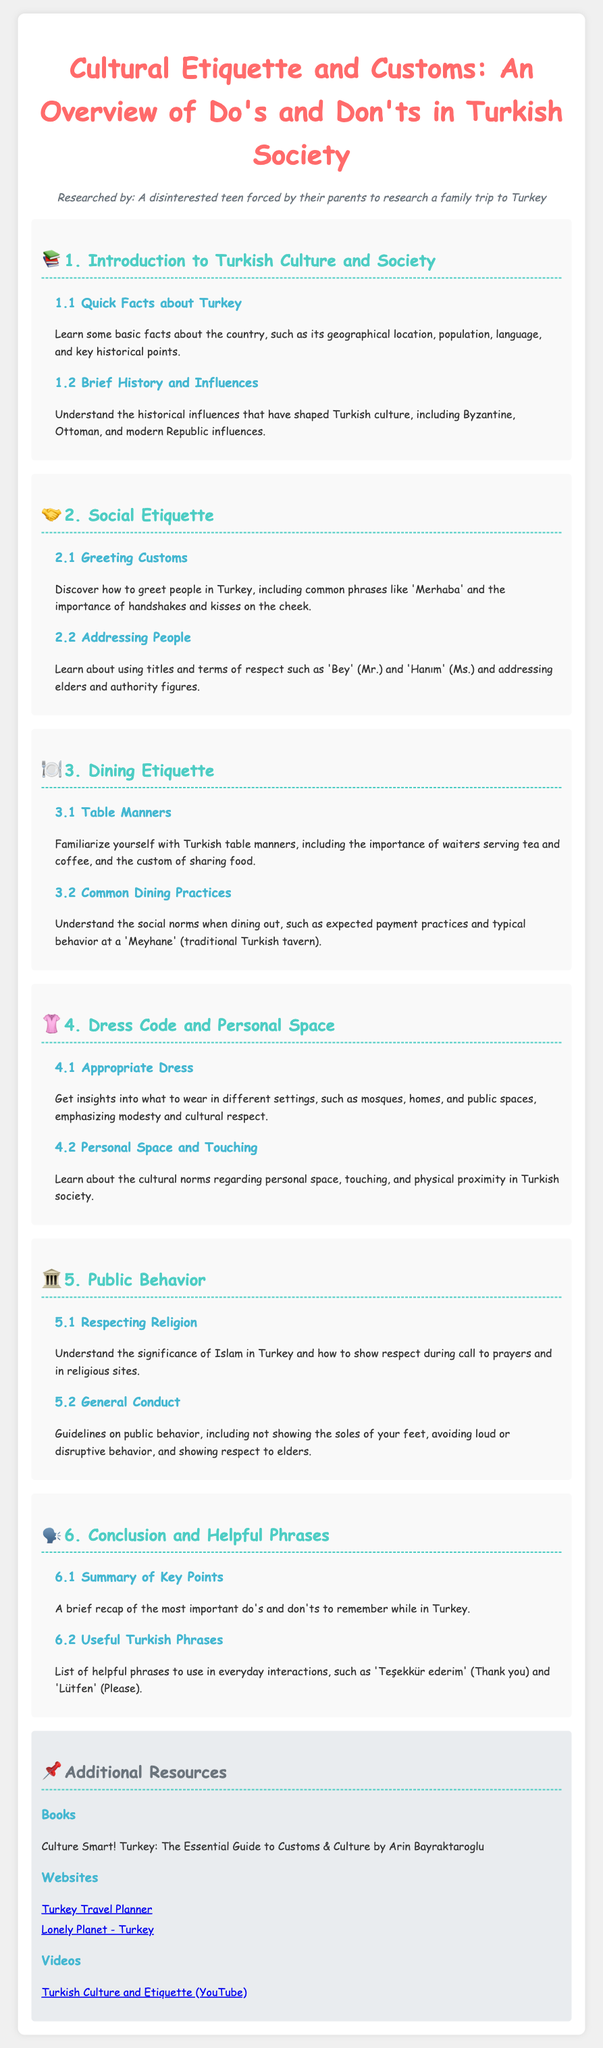what is the title of the document? The title is presented at the top of the rendered document in a large font.
Answer: Cultural Etiquette and Customs: An Overview of Do's and Don'ts in Turkish Society how many main modules are in the syllabus? The syllabus is divided into several modules, numbered sequentially.
Answer: 6 what is the Turkish phrase for 'thank you'? The phrase is listed under useful phrases at the end of the document.
Answer: Teşekkür ederim what cultural influence is mentioned as shaping Turkish society? The document discusses several influences in section 1.2.
Answer: Ottoman what should you not show in public according to general conduct? This is listed in the public behavior section of the document.
Answer: Soles of your feet how do people greet each other in Turkey? The first social etiquette section provides this information.
Answer: Merhaba what is commonly served at Turkish tables? The dining etiquette section highlights important cultural practices.
Answer: Tea and coffee what is the purpose of the resources section? This section provides additional materials for further reading and understanding.
Answer: Additional Resources 